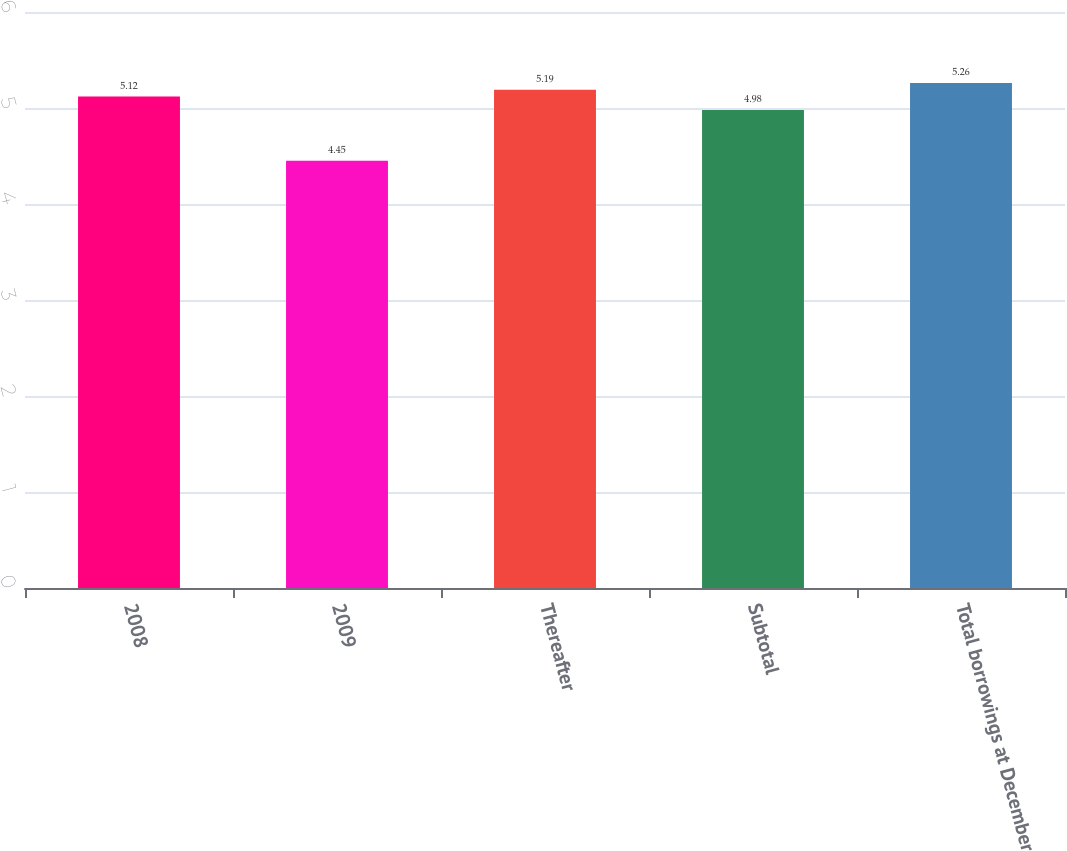<chart> <loc_0><loc_0><loc_500><loc_500><bar_chart><fcel>2008<fcel>2009<fcel>Thereafter<fcel>Subtotal<fcel>Total borrowings at December<nl><fcel>5.12<fcel>4.45<fcel>5.19<fcel>4.98<fcel>5.26<nl></chart> 